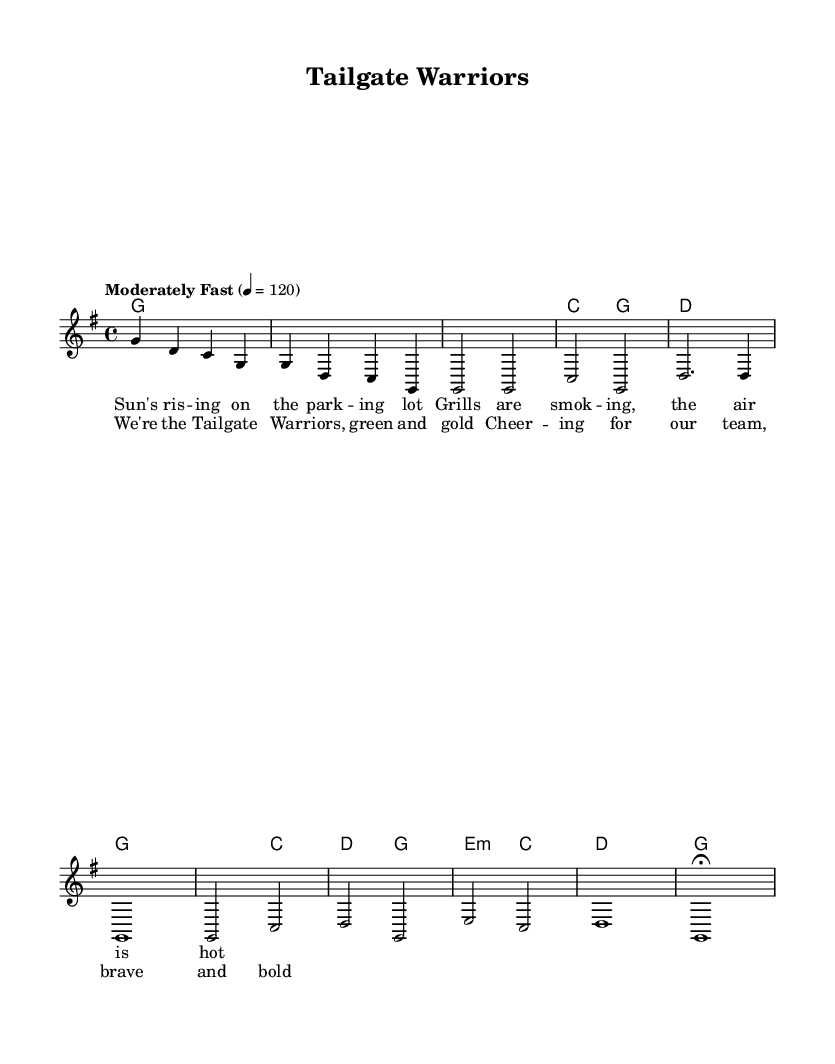What is the key signature of this music? The key signature is shown at the beginning of the staff, indicating that it is G major, which has one sharp (F#).
Answer: G major What is the time signature of the piece? The time signature is found at the beginning of the score and is indicated as 4/4, which means there are four beats in each measure.
Answer: 4/4 What is the tempo marking for the piece? The tempo marking is visible at the top of the sheet music and it states "Moderately Fast" with a metronome marking of quarter note equals 120 beats per minute.
Answer: Moderately Fast, 120 In which section does the chorus appear? By analyzing the structure of the sheet music, the chorus is indicated after the verse, typically following specific notation. In this case, it follows the first verse and is labeled in the lyrics section.
Answer: After the verse What type of chord is used in the chorus starting with E? Looking at the chord progression indicated in the harmonies, the chord labeled as "e:m" indicates it is an E minor chord, which includes the notes E, G, and B.
Answer: E minor How many measures are in the intro? Counting the measures in the melody section, there are a total of two measures labeled as the intro which are indicated before the verse begins.
Answer: 2 measures What is the lyrical theme of the song? By examining the lyrics in the score, the song's lyrics reflect excitement and camaraderie, typical for tailgating and football, emphasizing themes of gathering and cheering for the team.
Answer: Tailgating and football excitement 